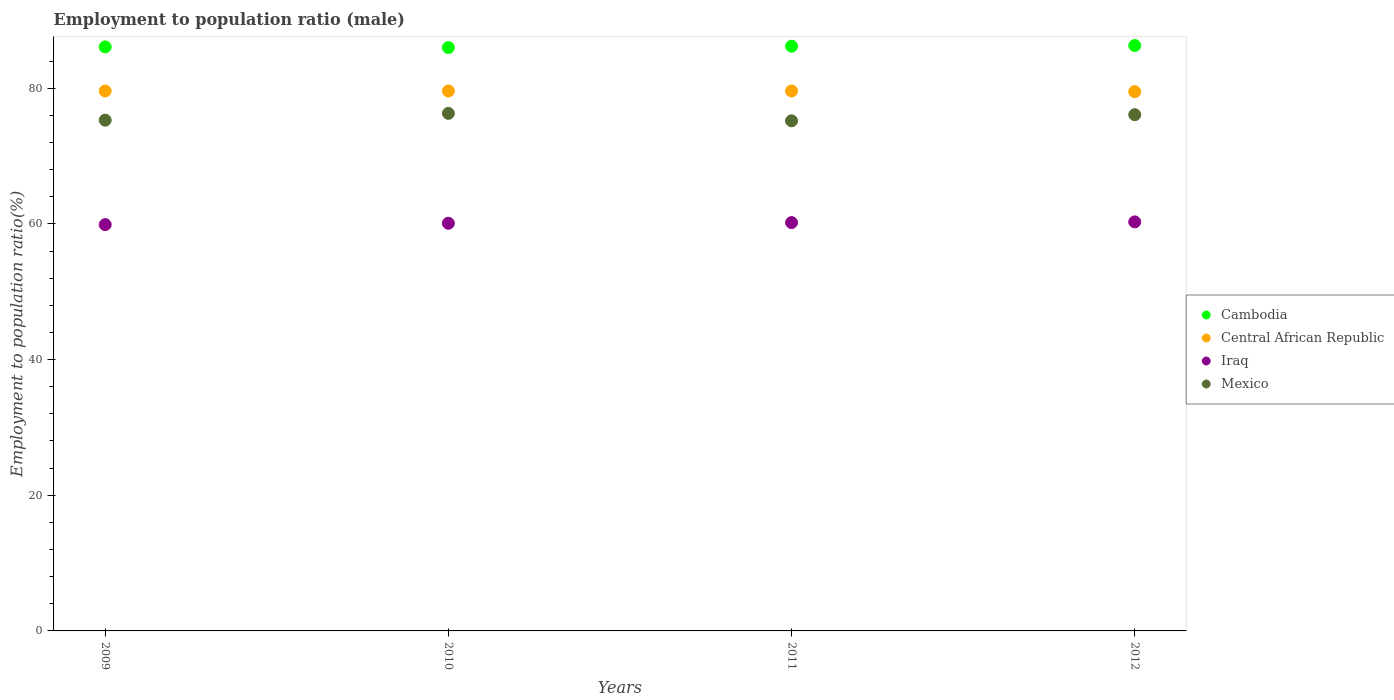Is the number of dotlines equal to the number of legend labels?
Your response must be concise. Yes. What is the employment to population ratio in Mexico in 2012?
Make the answer very short. 76.1. Across all years, what is the maximum employment to population ratio in Iraq?
Keep it short and to the point. 60.3. Across all years, what is the minimum employment to population ratio in Iraq?
Your answer should be compact. 59.9. In which year was the employment to population ratio in Iraq minimum?
Provide a short and direct response. 2009. What is the total employment to population ratio in Mexico in the graph?
Ensure brevity in your answer.  302.9. What is the difference between the employment to population ratio in Mexico in 2011 and that in 2012?
Your answer should be compact. -0.9. What is the difference between the employment to population ratio in Cambodia in 2011 and the employment to population ratio in Mexico in 2009?
Provide a short and direct response. 10.9. What is the average employment to population ratio in Iraq per year?
Offer a very short reply. 60.12. In the year 2011, what is the difference between the employment to population ratio in Iraq and employment to population ratio in Central African Republic?
Keep it short and to the point. -19.4. In how many years, is the employment to population ratio in Iraq greater than 4 %?
Ensure brevity in your answer.  4. Is the difference between the employment to population ratio in Iraq in 2009 and 2011 greater than the difference between the employment to population ratio in Central African Republic in 2009 and 2011?
Make the answer very short. No. What is the difference between the highest and the lowest employment to population ratio in Iraq?
Provide a succinct answer. 0.4. In how many years, is the employment to population ratio in Central African Republic greater than the average employment to population ratio in Central African Republic taken over all years?
Your answer should be compact. 3. Is it the case that in every year, the sum of the employment to population ratio in Central African Republic and employment to population ratio in Cambodia  is greater than the sum of employment to population ratio in Iraq and employment to population ratio in Mexico?
Offer a terse response. Yes. Is it the case that in every year, the sum of the employment to population ratio in Cambodia and employment to population ratio in Central African Republic  is greater than the employment to population ratio in Iraq?
Your answer should be compact. Yes. Does the employment to population ratio in Central African Republic monotonically increase over the years?
Give a very brief answer. No. Is the employment to population ratio in Central African Republic strictly greater than the employment to population ratio in Cambodia over the years?
Make the answer very short. No. How many dotlines are there?
Offer a very short reply. 4. How many years are there in the graph?
Give a very brief answer. 4. Are the values on the major ticks of Y-axis written in scientific E-notation?
Keep it short and to the point. No. Does the graph contain any zero values?
Your answer should be compact. No. Does the graph contain grids?
Your response must be concise. No. Where does the legend appear in the graph?
Make the answer very short. Center right. What is the title of the graph?
Ensure brevity in your answer.  Employment to population ratio (male). Does "Paraguay" appear as one of the legend labels in the graph?
Offer a very short reply. No. What is the Employment to population ratio(%) of Cambodia in 2009?
Provide a short and direct response. 86.1. What is the Employment to population ratio(%) in Central African Republic in 2009?
Your response must be concise. 79.6. What is the Employment to population ratio(%) of Iraq in 2009?
Provide a short and direct response. 59.9. What is the Employment to population ratio(%) in Mexico in 2009?
Your response must be concise. 75.3. What is the Employment to population ratio(%) in Central African Republic in 2010?
Provide a succinct answer. 79.6. What is the Employment to population ratio(%) in Iraq in 2010?
Ensure brevity in your answer.  60.1. What is the Employment to population ratio(%) in Mexico in 2010?
Provide a succinct answer. 76.3. What is the Employment to population ratio(%) in Cambodia in 2011?
Ensure brevity in your answer.  86.2. What is the Employment to population ratio(%) in Central African Republic in 2011?
Your answer should be very brief. 79.6. What is the Employment to population ratio(%) in Iraq in 2011?
Ensure brevity in your answer.  60.2. What is the Employment to population ratio(%) of Mexico in 2011?
Offer a terse response. 75.2. What is the Employment to population ratio(%) of Cambodia in 2012?
Ensure brevity in your answer.  86.3. What is the Employment to population ratio(%) of Central African Republic in 2012?
Ensure brevity in your answer.  79.5. What is the Employment to population ratio(%) of Iraq in 2012?
Your answer should be very brief. 60.3. What is the Employment to population ratio(%) of Mexico in 2012?
Provide a succinct answer. 76.1. Across all years, what is the maximum Employment to population ratio(%) in Cambodia?
Offer a very short reply. 86.3. Across all years, what is the maximum Employment to population ratio(%) in Central African Republic?
Give a very brief answer. 79.6. Across all years, what is the maximum Employment to population ratio(%) in Iraq?
Provide a succinct answer. 60.3. Across all years, what is the maximum Employment to population ratio(%) of Mexico?
Offer a terse response. 76.3. Across all years, what is the minimum Employment to population ratio(%) of Cambodia?
Keep it short and to the point. 86. Across all years, what is the minimum Employment to population ratio(%) in Central African Republic?
Your answer should be compact. 79.5. Across all years, what is the minimum Employment to population ratio(%) of Iraq?
Offer a very short reply. 59.9. Across all years, what is the minimum Employment to population ratio(%) of Mexico?
Offer a very short reply. 75.2. What is the total Employment to population ratio(%) of Cambodia in the graph?
Make the answer very short. 344.6. What is the total Employment to population ratio(%) of Central African Republic in the graph?
Your answer should be compact. 318.3. What is the total Employment to population ratio(%) in Iraq in the graph?
Give a very brief answer. 240.5. What is the total Employment to population ratio(%) in Mexico in the graph?
Your response must be concise. 302.9. What is the difference between the Employment to population ratio(%) in Cambodia in 2009 and that in 2010?
Offer a very short reply. 0.1. What is the difference between the Employment to population ratio(%) of Central African Republic in 2009 and that in 2010?
Provide a short and direct response. 0. What is the difference between the Employment to population ratio(%) in Iraq in 2009 and that in 2010?
Provide a succinct answer. -0.2. What is the difference between the Employment to population ratio(%) in Mexico in 2009 and that in 2010?
Provide a succinct answer. -1. What is the difference between the Employment to population ratio(%) of Cambodia in 2009 and that in 2011?
Offer a terse response. -0.1. What is the difference between the Employment to population ratio(%) in Mexico in 2009 and that in 2011?
Ensure brevity in your answer.  0.1. What is the difference between the Employment to population ratio(%) of Central African Republic in 2009 and that in 2012?
Give a very brief answer. 0.1. What is the difference between the Employment to population ratio(%) of Iraq in 2009 and that in 2012?
Give a very brief answer. -0.4. What is the difference between the Employment to population ratio(%) of Mexico in 2009 and that in 2012?
Offer a very short reply. -0.8. What is the difference between the Employment to population ratio(%) in Cambodia in 2010 and that in 2011?
Your answer should be very brief. -0.2. What is the difference between the Employment to population ratio(%) of Central African Republic in 2010 and that in 2011?
Offer a terse response. 0. What is the difference between the Employment to population ratio(%) of Mexico in 2010 and that in 2011?
Keep it short and to the point. 1.1. What is the difference between the Employment to population ratio(%) in Cambodia in 2010 and that in 2012?
Your answer should be compact. -0.3. What is the difference between the Employment to population ratio(%) of Iraq in 2010 and that in 2012?
Provide a succinct answer. -0.2. What is the difference between the Employment to population ratio(%) in Mexico in 2010 and that in 2012?
Your answer should be very brief. 0.2. What is the difference between the Employment to population ratio(%) in Central African Republic in 2011 and that in 2012?
Ensure brevity in your answer.  0.1. What is the difference between the Employment to population ratio(%) of Iraq in 2011 and that in 2012?
Offer a very short reply. -0.1. What is the difference between the Employment to population ratio(%) of Mexico in 2011 and that in 2012?
Offer a very short reply. -0.9. What is the difference between the Employment to population ratio(%) of Cambodia in 2009 and the Employment to population ratio(%) of Central African Republic in 2010?
Give a very brief answer. 6.5. What is the difference between the Employment to population ratio(%) in Cambodia in 2009 and the Employment to population ratio(%) in Iraq in 2010?
Provide a short and direct response. 26. What is the difference between the Employment to population ratio(%) of Cambodia in 2009 and the Employment to population ratio(%) of Mexico in 2010?
Your answer should be very brief. 9.8. What is the difference between the Employment to population ratio(%) in Central African Republic in 2009 and the Employment to population ratio(%) in Mexico in 2010?
Provide a succinct answer. 3.3. What is the difference between the Employment to population ratio(%) in Iraq in 2009 and the Employment to population ratio(%) in Mexico in 2010?
Ensure brevity in your answer.  -16.4. What is the difference between the Employment to population ratio(%) of Cambodia in 2009 and the Employment to population ratio(%) of Central African Republic in 2011?
Your response must be concise. 6.5. What is the difference between the Employment to population ratio(%) in Cambodia in 2009 and the Employment to population ratio(%) in Iraq in 2011?
Provide a succinct answer. 25.9. What is the difference between the Employment to population ratio(%) in Central African Republic in 2009 and the Employment to population ratio(%) in Mexico in 2011?
Offer a very short reply. 4.4. What is the difference between the Employment to population ratio(%) of Iraq in 2009 and the Employment to population ratio(%) of Mexico in 2011?
Keep it short and to the point. -15.3. What is the difference between the Employment to population ratio(%) of Cambodia in 2009 and the Employment to population ratio(%) of Iraq in 2012?
Keep it short and to the point. 25.8. What is the difference between the Employment to population ratio(%) in Cambodia in 2009 and the Employment to population ratio(%) in Mexico in 2012?
Provide a short and direct response. 10. What is the difference between the Employment to population ratio(%) in Central African Republic in 2009 and the Employment to population ratio(%) in Iraq in 2012?
Offer a very short reply. 19.3. What is the difference between the Employment to population ratio(%) of Central African Republic in 2009 and the Employment to population ratio(%) of Mexico in 2012?
Give a very brief answer. 3.5. What is the difference between the Employment to population ratio(%) in Iraq in 2009 and the Employment to population ratio(%) in Mexico in 2012?
Provide a short and direct response. -16.2. What is the difference between the Employment to population ratio(%) in Cambodia in 2010 and the Employment to population ratio(%) in Central African Republic in 2011?
Offer a very short reply. 6.4. What is the difference between the Employment to population ratio(%) of Cambodia in 2010 and the Employment to population ratio(%) of Iraq in 2011?
Provide a succinct answer. 25.8. What is the difference between the Employment to population ratio(%) of Cambodia in 2010 and the Employment to population ratio(%) of Mexico in 2011?
Ensure brevity in your answer.  10.8. What is the difference between the Employment to population ratio(%) of Iraq in 2010 and the Employment to population ratio(%) of Mexico in 2011?
Provide a short and direct response. -15.1. What is the difference between the Employment to population ratio(%) of Cambodia in 2010 and the Employment to population ratio(%) of Central African Republic in 2012?
Keep it short and to the point. 6.5. What is the difference between the Employment to population ratio(%) in Cambodia in 2010 and the Employment to population ratio(%) in Iraq in 2012?
Keep it short and to the point. 25.7. What is the difference between the Employment to population ratio(%) in Central African Republic in 2010 and the Employment to population ratio(%) in Iraq in 2012?
Offer a terse response. 19.3. What is the difference between the Employment to population ratio(%) of Central African Republic in 2010 and the Employment to population ratio(%) of Mexico in 2012?
Keep it short and to the point. 3.5. What is the difference between the Employment to population ratio(%) of Iraq in 2010 and the Employment to population ratio(%) of Mexico in 2012?
Make the answer very short. -16. What is the difference between the Employment to population ratio(%) in Cambodia in 2011 and the Employment to population ratio(%) in Central African Republic in 2012?
Keep it short and to the point. 6.7. What is the difference between the Employment to population ratio(%) of Cambodia in 2011 and the Employment to population ratio(%) of Iraq in 2012?
Offer a very short reply. 25.9. What is the difference between the Employment to population ratio(%) in Cambodia in 2011 and the Employment to population ratio(%) in Mexico in 2012?
Provide a short and direct response. 10.1. What is the difference between the Employment to population ratio(%) of Central African Republic in 2011 and the Employment to population ratio(%) of Iraq in 2012?
Give a very brief answer. 19.3. What is the difference between the Employment to population ratio(%) in Iraq in 2011 and the Employment to population ratio(%) in Mexico in 2012?
Ensure brevity in your answer.  -15.9. What is the average Employment to population ratio(%) of Cambodia per year?
Provide a succinct answer. 86.15. What is the average Employment to population ratio(%) in Central African Republic per year?
Ensure brevity in your answer.  79.58. What is the average Employment to population ratio(%) in Iraq per year?
Offer a terse response. 60.12. What is the average Employment to population ratio(%) of Mexico per year?
Keep it short and to the point. 75.72. In the year 2009, what is the difference between the Employment to population ratio(%) of Cambodia and Employment to population ratio(%) of Central African Republic?
Your response must be concise. 6.5. In the year 2009, what is the difference between the Employment to population ratio(%) in Cambodia and Employment to population ratio(%) in Iraq?
Keep it short and to the point. 26.2. In the year 2009, what is the difference between the Employment to population ratio(%) in Central African Republic and Employment to population ratio(%) in Mexico?
Your answer should be very brief. 4.3. In the year 2009, what is the difference between the Employment to population ratio(%) in Iraq and Employment to population ratio(%) in Mexico?
Your answer should be very brief. -15.4. In the year 2010, what is the difference between the Employment to population ratio(%) of Cambodia and Employment to population ratio(%) of Iraq?
Ensure brevity in your answer.  25.9. In the year 2010, what is the difference between the Employment to population ratio(%) in Cambodia and Employment to population ratio(%) in Mexico?
Your response must be concise. 9.7. In the year 2010, what is the difference between the Employment to population ratio(%) in Iraq and Employment to population ratio(%) in Mexico?
Ensure brevity in your answer.  -16.2. In the year 2011, what is the difference between the Employment to population ratio(%) of Cambodia and Employment to population ratio(%) of Central African Republic?
Your answer should be compact. 6.6. In the year 2011, what is the difference between the Employment to population ratio(%) of Cambodia and Employment to population ratio(%) of Iraq?
Offer a very short reply. 26. In the year 2011, what is the difference between the Employment to population ratio(%) in Cambodia and Employment to population ratio(%) in Mexico?
Your answer should be very brief. 11. In the year 2011, what is the difference between the Employment to population ratio(%) in Central African Republic and Employment to population ratio(%) in Iraq?
Keep it short and to the point. 19.4. In the year 2011, what is the difference between the Employment to population ratio(%) of Iraq and Employment to population ratio(%) of Mexico?
Your answer should be very brief. -15. In the year 2012, what is the difference between the Employment to population ratio(%) in Cambodia and Employment to population ratio(%) in Central African Republic?
Provide a short and direct response. 6.8. In the year 2012, what is the difference between the Employment to population ratio(%) in Central African Republic and Employment to population ratio(%) in Iraq?
Your answer should be very brief. 19.2. In the year 2012, what is the difference between the Employment to population ratio(%) in Iraq and Employment to population ratio(%) in Mexico?
Provide a short and direct response. -15.8. What is the ratio of the Employment to population ratio(%) in Cambodia in 2009 to that in 2010?
Give a very brief answer. 1. What is the ratio of the Employment to population ratio(%) of Central African Republic in 2009 to that in 2010?
Provide a succinct answer. 1. What is the ratio of the Employment to population ratio(%) in Mexico in 2009 to that in 2010?
Offer a terse response. 0.99. What is the ratio of the Employment to population ratio(%) in Cambodia in 2009 to that in 2011?
Your response must be concise. 1. What is the ratio of the Employment to population ratio(%) of Central African Republic in 2009 to that in 2011?
Your answer should be very brief. 1. What is the ratio of the Employment to population ratio(%) of Mexico in 2009 to that in 2011?
Make the answer very short. 1. What is the ratio of the Employment to population ratio(%) of Cambodia in 2009 to that in 2012?
Offer a terse response. 1. What is the ratio of the Employment to population ratio(%) in Central African Republic in 2009 to that in 2012?
Your answer should be compact. 1. What is the ratio of the Employment to population ratio(%) in Iraq in 2010 to that in 2011?
Offer a terse response. 1. What is the ratio of the Employment to population ratio(%) of Mexico in 2010 to that in 2011?
Keep it short and to the point. 1.01. What is the ratio of the Employment to population ratio(%) of Cambodia in 2010 to that in 2012?
Provide a succinct answer. 1. What is the ratio of the Employment to population ratio(%) of Central African Republic in 2010 to that in 2012?
Offer a terse response. 1. What is the ratio of the Employment to population ratio(%) of Iraq in 2010 to that in 2012?
Offer a very short reply. 1. What is the ratio of the Employment to population ratio(%) in Mexico in 2010 to that in 2012?
Make the answer very short. 1. What is the ratio of the Employment to population ratio(%) of Iraq in 2011 to that in 2012?
Keep it short and to the point. 1. What is the difference between the highest and the second highest Employment to population ratio(%) in Central African Republic?
Keep it short and to the point. 0. What is the difference between the highest and the lowest Employment to population ratio(%) in Cambodia?
Your response must be concise. 0.3. What is the difference between the highest and the lowest Employment to population ratio(%) of Central African Republic?
Make the answer very short. 0.1. What is the difference between the highest and the lowest Employment to population ratio(%) of Iraq?
Give a very brief answer. 0.4. What is the difference between the highest and the lowest Employment to population ratio(%) in Mexico?
Your response must be concise. 1.1. 